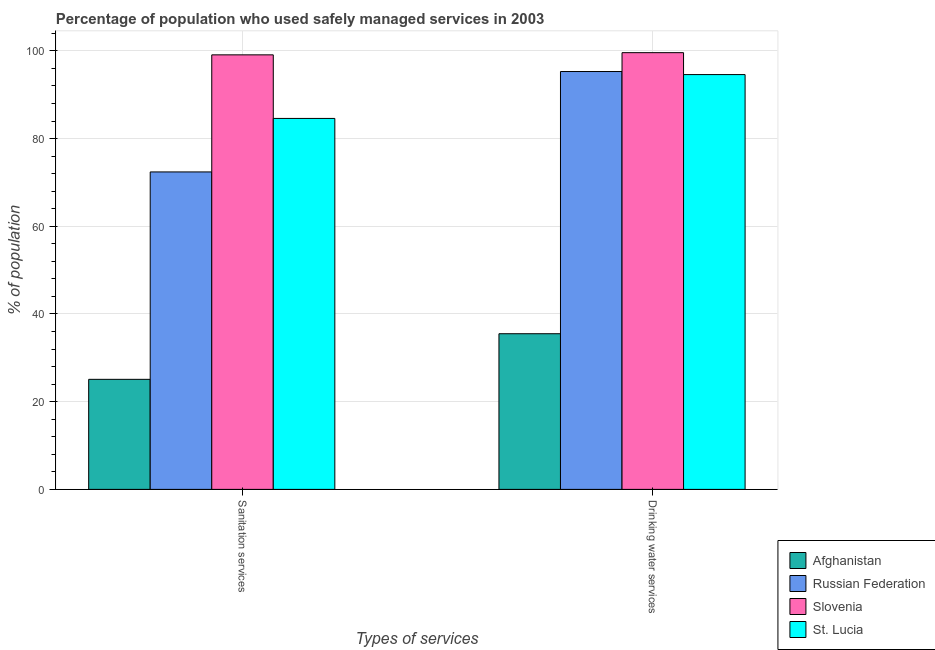Are the number of bars on each tick of the X-axis equal?
Give a very brief answer. Yes. How many bars are there on the 2nd tick from the left?
Keep it short and to the point. 4. What is the label of the 1st group of bars from the left?
Give a very brief answer. Sanitation services. What is the percentage of population who used sanitation services in Slovenia?
Offer a terse response. 99.1. Across all countries, what is the maximum percentage of population who used drinking water services?
Offer a terse response. 99.6. Across all countries, what is the minimum percentage of population who used sanitation services?
Ensure brevity in your answer.  25.1. In which country was the percentage of population who used drinking water services maximum?
Your answer should be very brief. Slovenia. In which country was the percentage of population who used sanitation services minimum?
Make the answer very short. Afghanistan. What is the total percentage of population who used drinking water services in the graph?
Your response must be concise. 325. What is the difference between the percentage of population who used drinking water services in Russian Federation and that in Afghanistan?
Provide a succinct answer. 59.8. What is the difference between the percentage of population who used sanitation services in Russian Federation and the percentage of population who used drinking water services in Afghanistan?
Your response must be concise. 36.9. What is the average percentage of population who used drinking water services per country?
Make the answer very short. 81.25. What is the difference between the percentage of population who used drinking water services and percentage of population who used sanitation services in St. Lucia?
Provide a short and direct response. 10. What is the ratio of the percentage of population who used drinking water services in St. Lucia to that in Afghanistan?
Ensure brevity in your answer.  2.66. Is the percentage of population who used sanitation services in Afghanistan less than that in Russian Federation?
Your answer should be compact. Yes. In how many countries, is the percentage of population who used sanitation services greater than the average percentage of population who used sanitation services taken over all countries?
Provide a short and direct response. 3. What does the 4th bar from the left in Sanitation services represents?
Your answer should be very brief. St. Lucia. What does the 1st bar from the right in Sanitation services represents?
Your answer should be very brief. St. Lucia. What is the difference between two consecutive major ticks on the Y-axis?
Your response must be concise. 20. Does the graph contain grids?
Make the answer very short. Yes. Where does the legend appear in the graph?
Your answer should be very brief. Bottom right. How many legend labels are there?
Make the answer very short. 4. How are the legend labels stacked?
Offer a very short reply. Vertical. What is the title of the graph?
Ensure brevity in your answer.  Percentage of population who used safely managed services in 2003. What is the label or title of the X-axis?
Offer a very short reply. Types of services. What is the label or title of the Y-axis?
Offer a very short reply. % of population. What is the % of population of Afghanistan in Sanitation services?
Provide a succinct answer. 25.1. What is the % of population of Russian Federation in Sanitation services?
Give a very brief answer. 72.4. What is the % of population in Slovenia in Sanitation services?
Make the answer very short. 99.1. What is the % of population of St. Lucia in Sanitation services?
Give a very brief answer. 84.6. What is the % of population in Afghanistan in Drinking water services?
Your answer should be compact. 35.5. What is the % of population of Russian Federation in Drinking water services?
Ensure brevity in your answer.  95.3. What is the % of population in Slovenia in Drinking water services?
Offer a terse response. 99.6. What is the % of population in St. Lucia in Drinking water services?
Your answer should be very brief. 94.6. Across all Types of services, what is the maximum % of population of Afghanistan?
Your response must be concise. 35.5. Across all Types of services, what is the maximum % of population in Russian Federation?
Make the answer very short. 95.3. Across all Types of services, what is the maximum % of population in Slovenia?
Give a very brief answer. 99.6. Across all Types of services, what is the maximum % of population in St. Lucia?
Provide a succinct answer. 94.6. Across all Types of services, what is the minimum % of population of Afghanistan?
Provide a succinct answer. 25.1. Across all Types of services, what is the minimum % of population of Russian Federation?
Keep it short and to the point. 72.4. Across all Types of services, what is the minimum % of population in Slovenia?
Your response must be concise. 99.1. Across all Types of services, what is the minimum % of population in St. Lucia?
Ensure brevity in your answer.  84.6. What is the total % of population of Afghanistan in the graph?
Your response must be concise. 60.6. What is the total % of population in Russian Federation in the graph?
Provide a succinct answer. 167.7. What is the total % of population in Slovenia in the graph?
Offer a terse response. 198.7. What is the total % of population in St. Lucia in the graph?
Make the answer very short. 179.2. What is the difference between the % of population in Afghanistan in Sanitation services and that in Drinking water services?
Ensure brevity in your answer.  -10.4. What is the difference between the % of population of Russian Federation in Sanitation services and that in Drinking water services?
Give a very brief answer. -22.9. What is the difference between the % of population in Slovenia in Sanitation services and that in Drinking water services?
Your answer should be compact. -0.5. What is the difference between the % of population in Afghanistan in Sanitation services and the % of population in Russian Federation in Drinking water services?
Provide a succinct answer. -70.2. What is the difference between the % of population of Afghanistan in Sanitation services and the % of population of Slovenia in Drinking water services?
Offer a very short reply. -74.5. What is the difference between the % of population in Afghanistan in Sanitation services and the % of population in St. Lucia in Drinking water services?
Keep it short and to the point. -69.5. What is the difference between the % of population in Russian Federation in Sanitation services and the % of population in Slovenia in Drinking water services?
Provide a succinct answer. -27.2. What is the difference between the % of population of Russian Federation in Sanitation services and the % of population of St. Lucia in Drinking water services?
Your answer should be compact. -22.2. What is the average % of population of Afghanistan per Types of services?
Provide a short and direct response. 30.3. What is the average % of population of Russian Federation per Types of services?
Your response must be concise. 83.85. What is the average % of population in Slovenia per Types of services?
Offer a very short reply. 99.35. What is the average % of population in St. Lucia per Types of services?
Provide a short and direct response. 89.6. What is the difference between the % of population of Afghanistan and % of population of Russian Federation in Sanitation services?
Offer a very short reply. -47.3. What is the difference between the % of population in Afghanistan and % of population in Slovenia in Sanitation services?
Your answer should be very brief. -74. What is the difference between the % of population in Afghanistan and % of population in St. Lucia in Sanitation services?
Provide a short and direct response. -59.5. What is the difference between the % of population in Russian Federation and % of population in Slovenia in Sanitation services?
Your answer should be very brief. -26.7. What is the difference between the % of population in Russian Federation and % of population in St. Lucia in Sanitation services?
Make the answer very short. -12.2. What is the difference between the % of population of Afghanistan and % of population of Russian Federation in Drinking water services?
Ensure brevity in your answer.  -59.8. What is the difference between the % of population in Afghanistan and % of population in Slovenia in Drinking water services?
Offer a very short reply. -64.1. What is the difference between the % of population in Afghanistan and % of population in St. Lucia in Drinking water services?
Keep it short and to the point. -59.1. What is the difference between the % of population in Russian Federation and % of population in St. Lucia in Drinking water services?
Ensure brevity in your answer.  0.7. What is the difference between the % of population of Slovenia and % of population of St. Lucia in Drinking water services?
Your response must be concise. 5. What is the ratio of the % of population in Afghanistan in Sanitation services to that in Drinking water services?
Offer a very short reply. 0.71. What is the ratio of the % of population in Russian Federation in Sanitation services to that in Drinking water services?
Provide a succinct answer. 0.76. What is the ratio of the % of population in St. Lucia in Sanitation services to that in Drinking water services?
Provide a succinct answer. 0.89. What is the difference between the highest and the second highest % of population of Afghanistan?
Keep it short and to the point. 10.4. What is the difference between the highest and the second highest % of population in Russian Federation?
Your answer should be very brief. 22.9. What is the difference between the highest and the second highest % of population in Slovenia?
Keep it short and to the point. 0.5. What is the difference between the highest and the second highest % of population of St. Lucia?
Your answer should be compact. 10. What is the difference between the highest and the lowest % of population in Afghanistan?
Ensure brevity in your answer.  10.4. What is the difference between the highest and the lowest % of population of Russian Federation?
Offer a terse response. 22.9. What is the difference between the highest and the lowest % of population of St. Lucia?
Your response must be concise. 10. 